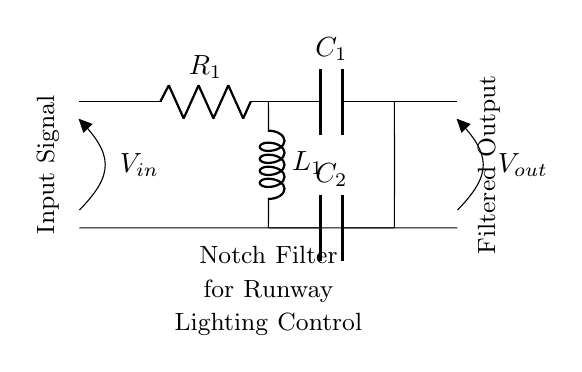What is the main purpose of this circuit? The main purpose of this circuit is to remove unwanted frequencies from the runway lighting control system. It is specifically designed to attenuate or eliminate specific frequency components that could interfere with the lighting control.
Answer: Remove unwanted frequencies What type of filter is shown in the circuit? The circuit represents a notch filter, which is specifically used to target and remove narrowband unwanted frequencies from a signal while allowing other frequencies to pass through.
Answer: Notch filter How many resistors are in the circuit? There is one resistor in the circuit, labeled R1, which is part of the input stage of the notch filter.
Answer: One What components are used in parallel in this circuit? In the circuit, capacitor C2 and inductor L1 are used in parallel. This configuration helps to create the notch effect at a specific frequency by allowing other frequencies to bypass them.
Answer: Capacitor C2 and inductor L1 What is the significance of the labeled input and output? The labeled input (Vin) indicates where the raw signal enters the notch filter, while the output (Vout) shows where the filtered signal exits. This is crucial for connecting the filter within the broader runway lighting control system.
Answer: Input and output At what point does the filtering occur? The filtering occurs between the capacitor C2 and inductor L1, as their parallel arrangement determines the frequency response of the circuit, effectively suppressing the unwanted frequencies.
Answer: Between C2 and L1 